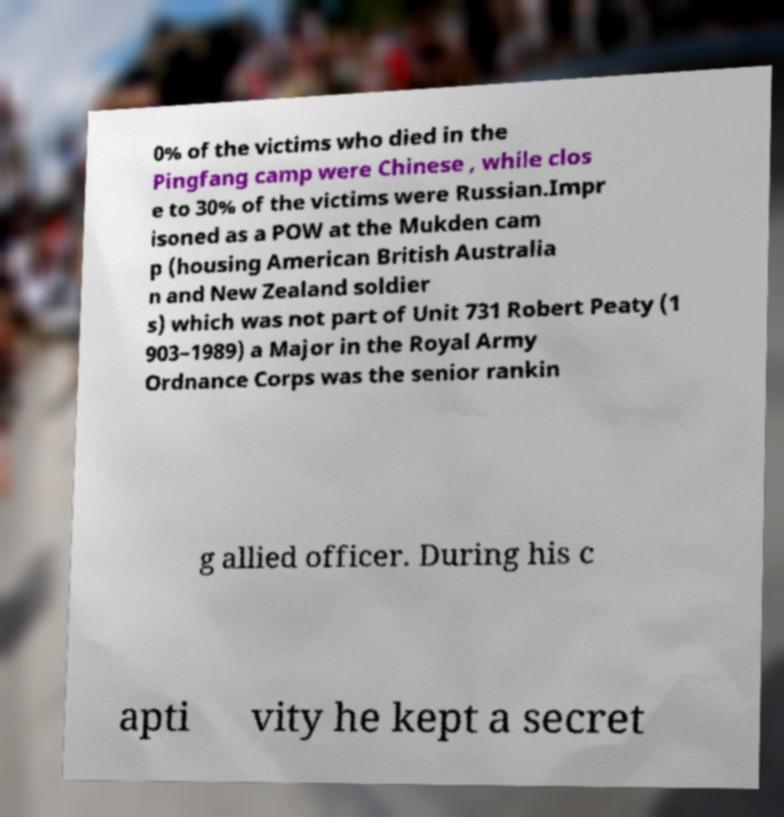Could you assist in decoding the text presented in this image and type it out clearly? 0% of the victims who died in the Pingfang camp were Chinese , while clos e to 30% of the victims were Russian.Impr isoned as a POW at the Mukden cam p (housing American British Australia n and New Zealand soldier s) which was not part of Unit 731 Robert Peaty (1 903–1989) a Major in the Royal Army Ordnance Corps was the senior rankin g allied officer. During his c apti vity he kept a secret 